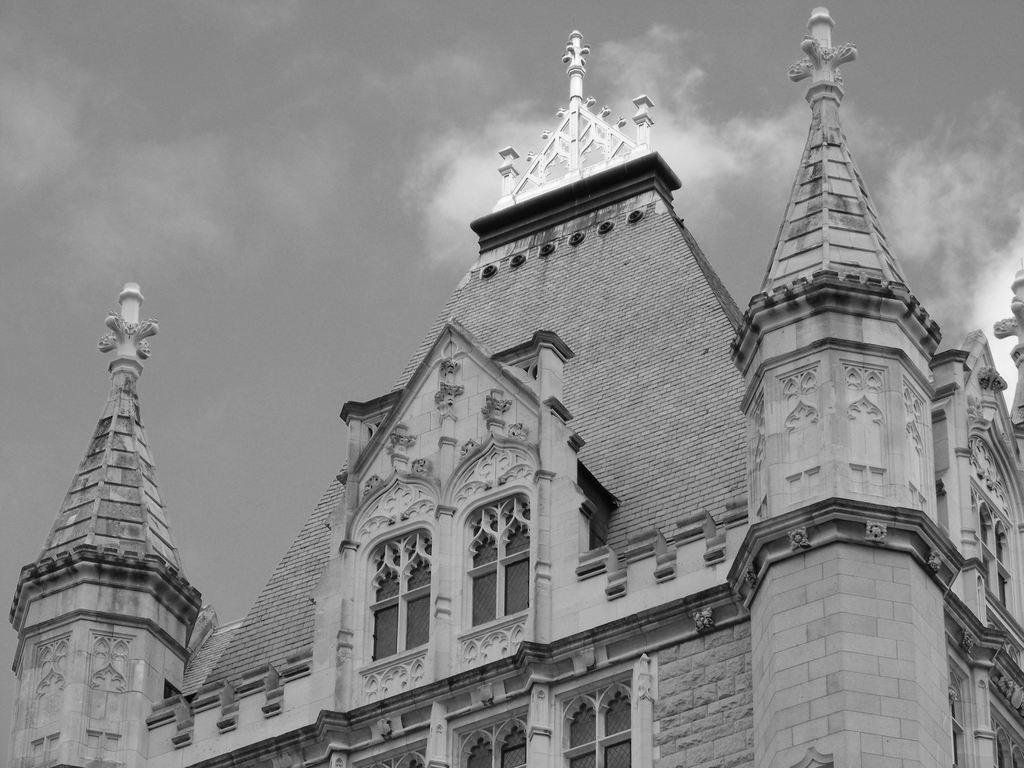What is the main subject of the picture? The main subject of the picture is a building. What specific features can be observed on the building? The building has windows. What can be seen in the background of the picture? The sky is visible in the background of the picture. What type of weather can be seen in the picture? The provided facts do not mention any specific weather conditions, so it cannot be determined from the image. Can you tell me how many people were shocked by the building in the picture? There is no indication in the image that anyone was shocked by the building, so it cannot be determined from the image. 